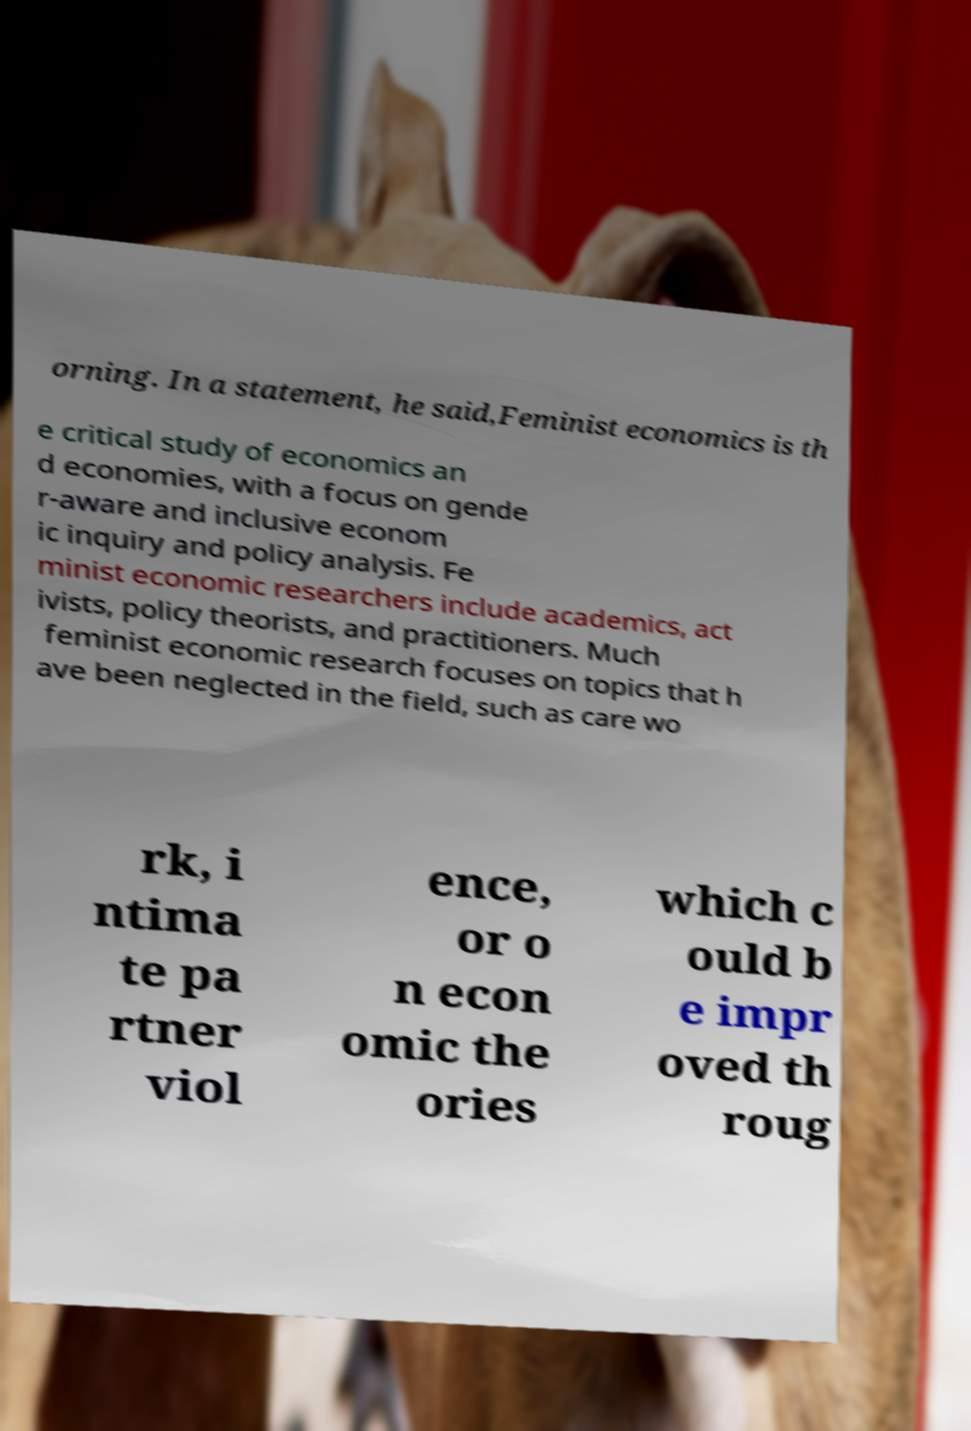Can you read and provide the text displayed in the image?This photo seems to have some interesting text. Can you extract and type it out for me? orning. In a statement, he said,Feminist economics is th e critical study of economics an d economies, with a focus on gende r-aware and inclusive econom ic inquiry and policy analysis. Fe minist economic researchers include academics, act ivists, policy theorists, and practitioners. Much feminist economic research focuses on topics that h ave been neglected in the field, such as care wo rk, i ntima te pa rtner viol ence, or o n econ omic the ories which c ould b e impr oved th roug 